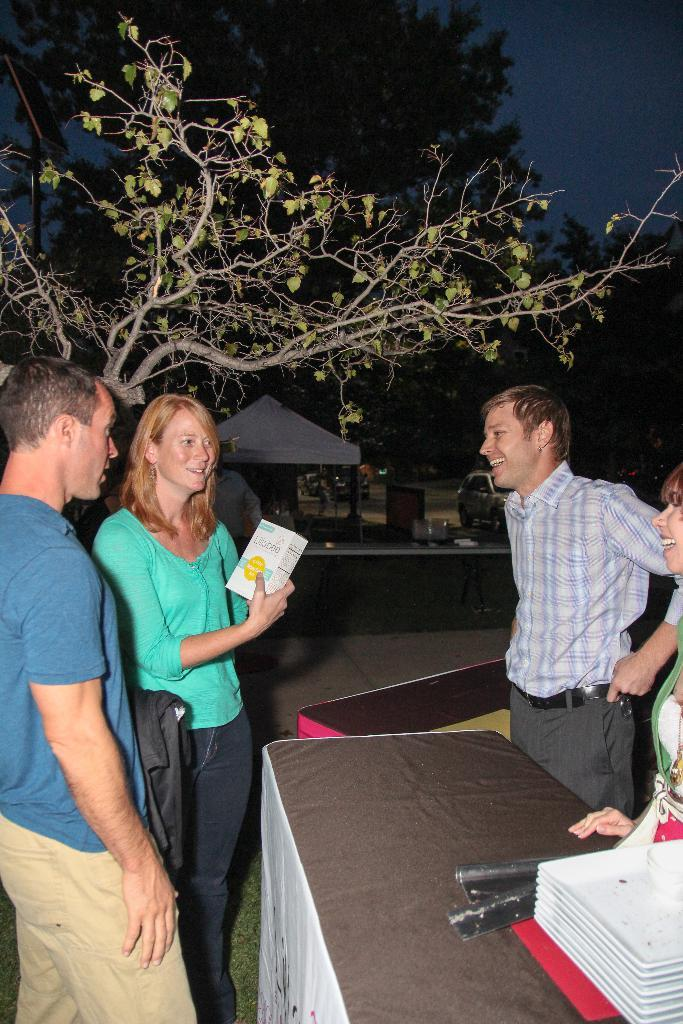What is happening with the group of people in the image? The people in the image are standing and smiling. What is present in the image besides the group of people? There is a table, objects on the table, a tree, and the sky visible in the image. Can you describe the table in the image? There is a table in the image, but the specific details of the table are not mentioned in the facts. What can be seen in the sky in the image? The sky is visible in the image, but the specific details of the sky are not mentioned in the facts. What type of art is being displayed on the shoes in the image? There are no shoes present in the image, so it is not possible to answer that question. 